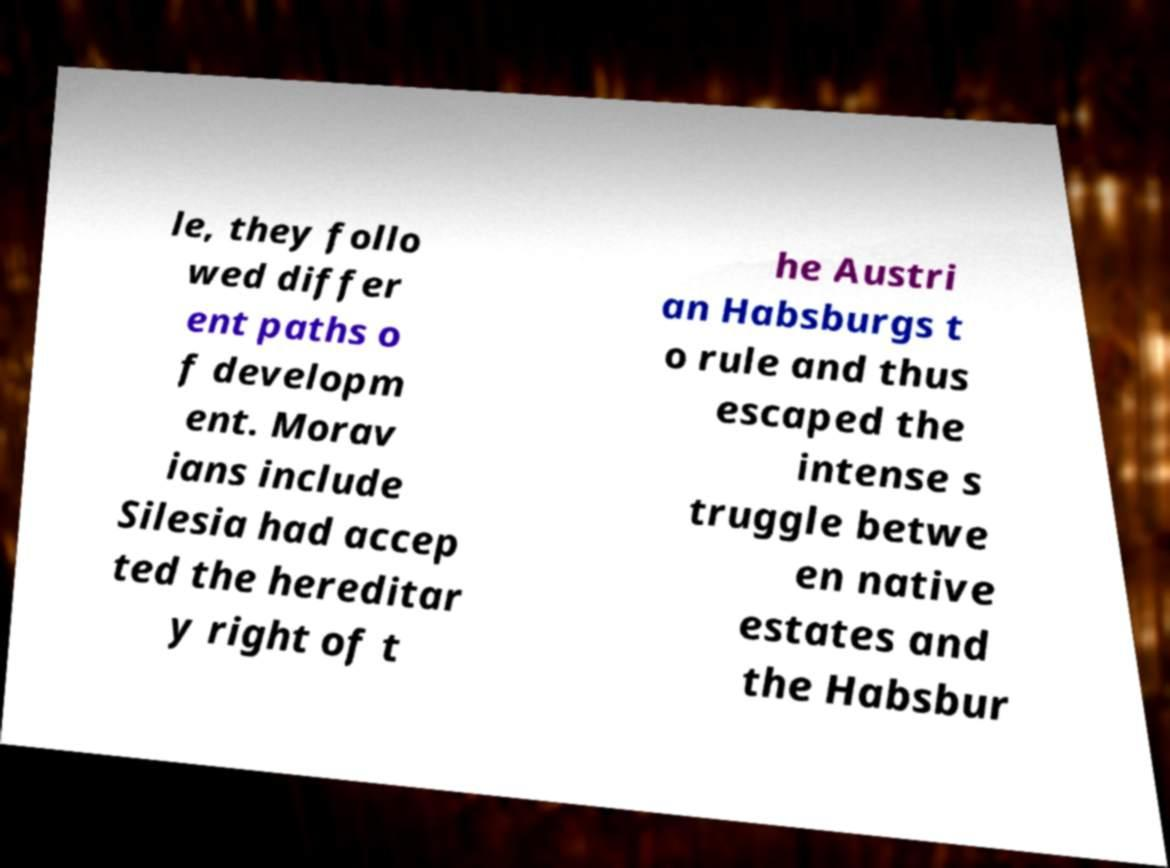Please read and relay the text visible in this image. What does it say? le, they follo wed differ ent paths o f developm ent. Morav ians include Silesia had accep ted the hereditar y right of t he Austri an Habsburgs t o rule and thus escaped the intense s truggle betwe en native estates and the Habsbur 